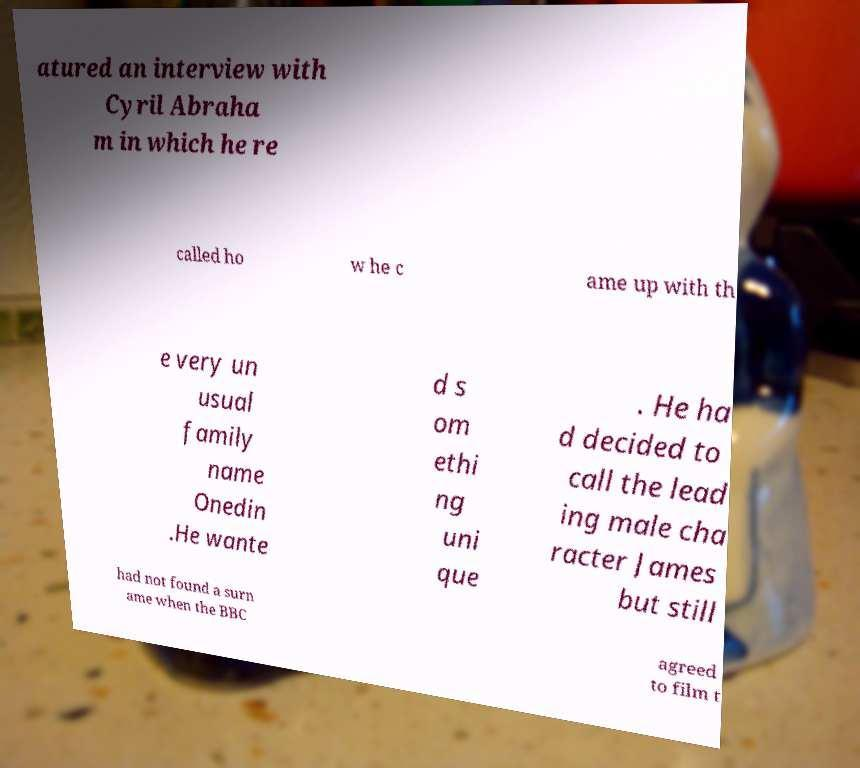What messages or text are displayed in this image? I need them in a readable, typed format. atured an interview with Cyril Abraha m in which he re called ho w he c ame up with th e very un usual family name Onedin .He wante d s om ethi ng uni que . He ha d decided to call the lead ing male cha racter James but still had not found a surn ame when the BBC agreed to film t 